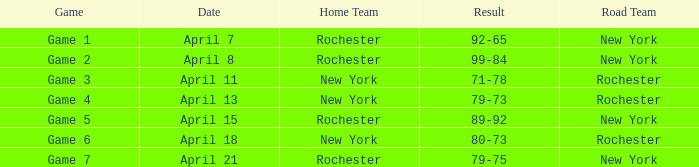Which Road Team has a Home Team of rochester, and a Game of game 2? New York. 